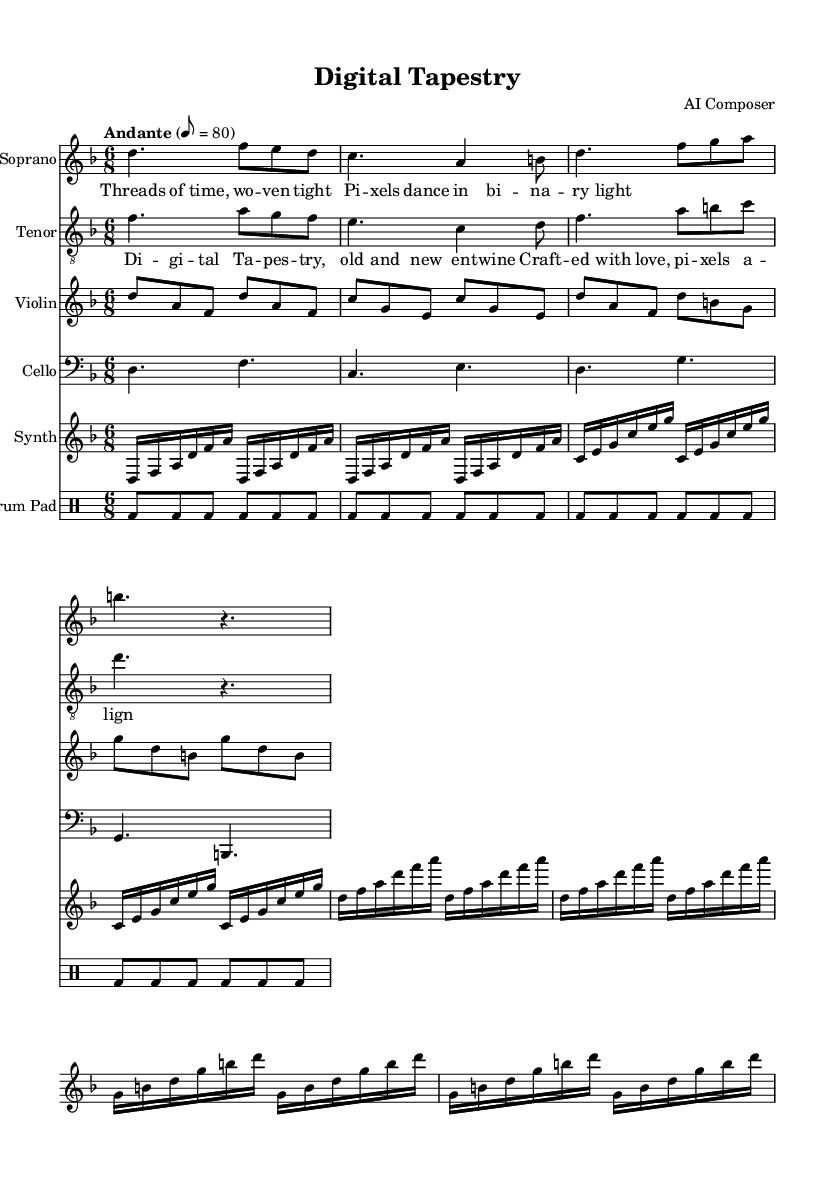what is the key signature of this music? The key signature shown in the global section of the music indicates D minor, as it has one flat (B flat).
Answer: D minor what is the time signature of this music? The time signature is noted at the beginning as 6/8, which means there are six eighth notes in each measure.
Answer: 6/8 what is the tempo marking for this piece? The tempo marking indicates "Andante" with a metronome setting of 80 beats per minute, suggesting a moderately slow pace.
Answer: Andante 80 how many instruments are featured in the score? Counting each staff in the score section reveals six distinct instruments: Soprano, Tenor, Violin, Cello, Synth, and Drum Pad.
Answer: Six what is the title of the opera piece? The title of the music is given in the header section as “Digital Tapestry,” which reflects its theme of blending digital and traditional elements.
Answer: Digital Tapestry what lyrical themes are presented in the verse? Analyzing the lyrics of the verse, it evokes themes of time and technology, illustrated by phrases like "Threads of time" and "pixels dance."
Answer: Time and technology how does the structure of this opera piece integrate different musical styles? The score incorporates traditional vocal elements (Soprano, Tenor) alongside modern instrumentation (Synth, Drum Pad), creating a fusion of classical and digital music styles.
Answer: Fusion of classical and digital 